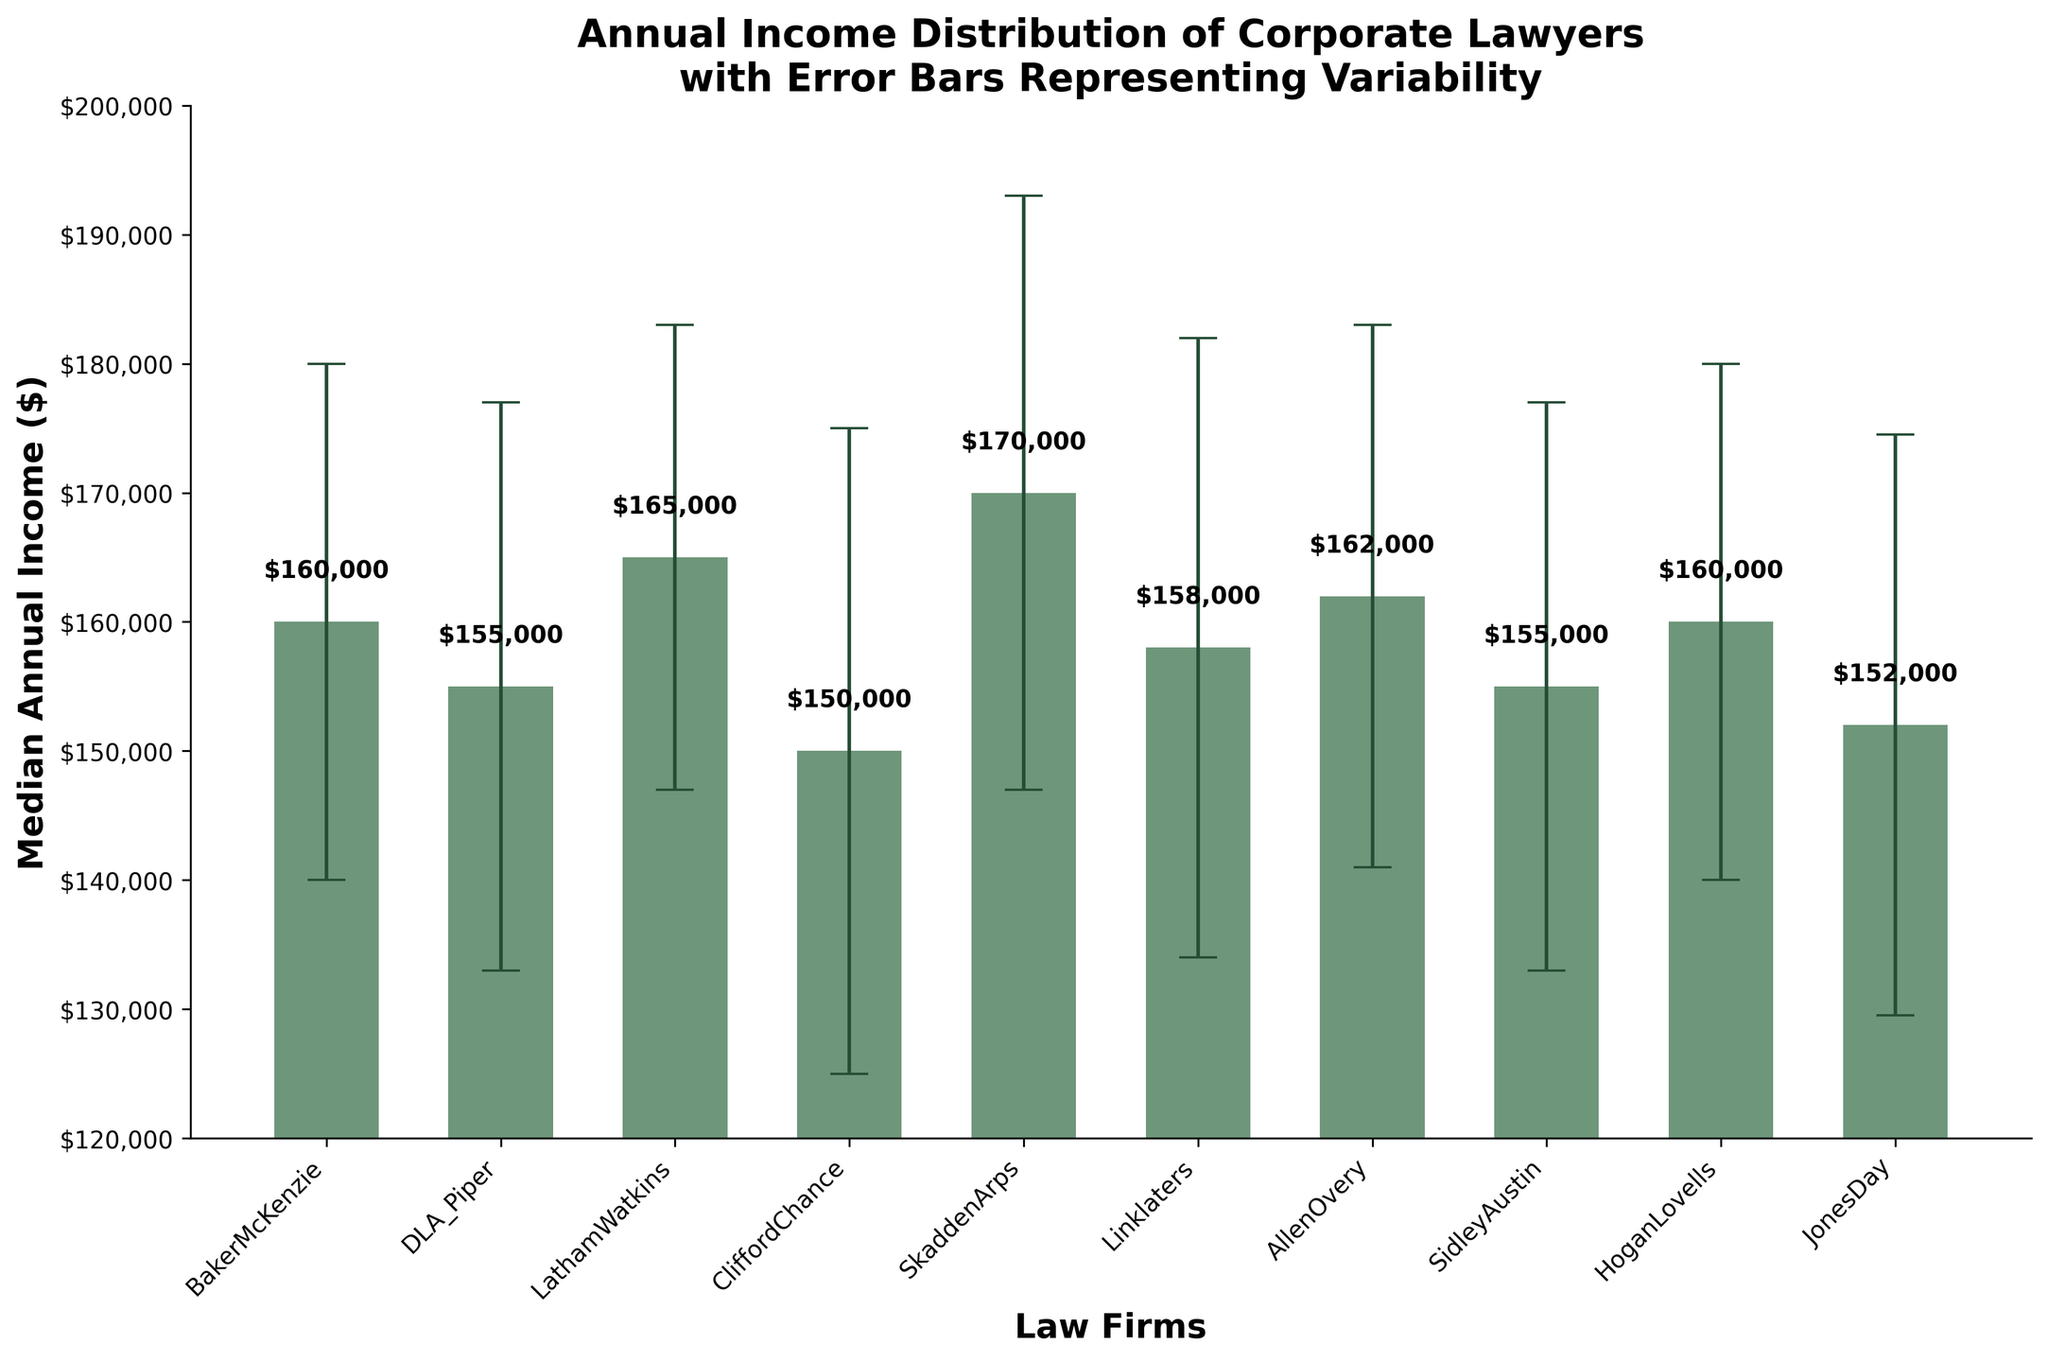What is the title of the figure? The title of the figure is displayed at the top and describes the overall contents of the plot, which helps viewers understand what the data represents.
Answer: Annual Income Distribution of Corporate Lawyers with Error Bars Representing Variability What is the median annual income for lawyers at Skadden Arps? Locate the bar corresponding to Skadden Arps and read the value at the top of the bar.
Answer: $170,000 Which law firm has the highest median annual income? Compare the heights of all the bars and identify the bar that reaches the highest point on the y-axis, which corresponds to the highest median annual income.
Answer: Latham Watkins What is the difference in median income between Clifford Chance and Jones Day? Read the values at the top of the bars for Clifford Chance and Jones Day, then subtract the smaller value from the larger one. $150,000 - $152,000 = -$2,000.
Answer: $2,000 Which law firms have median incomes between $155,000 and $160,000? Identify the bars that fall within the specified range by reading their median income values.
Answer: DLA Piper, Linklaters, Sidley Austin, and Hogan Lovells What does the error bar represent in this plot? Error bars show the variability in the median incomes of corporate lawyers among different law firms, indicating the standard deviation.
Answer: Variability/Standard deviation For which law firm is the variability in income the highest? Look at the length of the error bars and identify the firm with the longest error bar, indicating the largest standard deviation.
Answer: Clifford Chance What is the range of the y-axis in the plot? Examine the y-axis and note the lowest and highest values marked, which define the range.
Answer: $120,000 to $200,000 How does the error bar for Baker McKenzie compare to that for Allen & Overy? Compare the lengths of the error bars for the two law firms by examining the error bars above each respective bar.
Answer: Baker McKenzie's error bar is shorter Which law firm has a median income closest to $160,000? Locate the bar that is nearest to the $160,000 mark on the y-axis.
Answer: Baker McKenzie and Hogan Lovells 